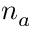<formula> <loc_0><loc_0><loc_500><loc_500>n _ { a }</formula> 